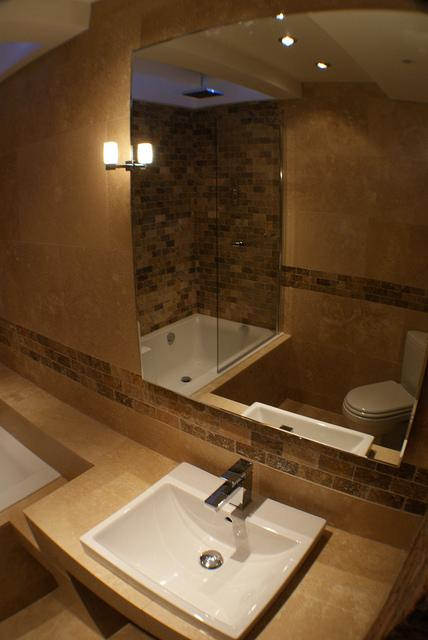Why is there no shower curtain?

Choices:
A) no shower
B) on floor
C) no bathtub
D) shower door shower door 